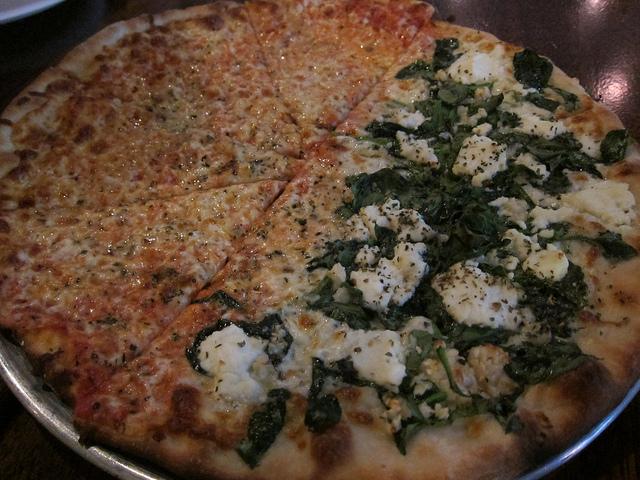Is this a traditional breakfast food?
Quick response, please. No. Are there olives in the photo?
Quick response, please. No. Is this a dessert?
Keep it brief. No. Are there two kind of pizza in one pan?
Concise answer only. Yes. What type of pizza is this?
Keep it brief. Spinach. 